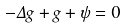<formula> <loc_0><loc_0><loc_500><loc_500>- \Delta g + g + \psi = 0</formula> 